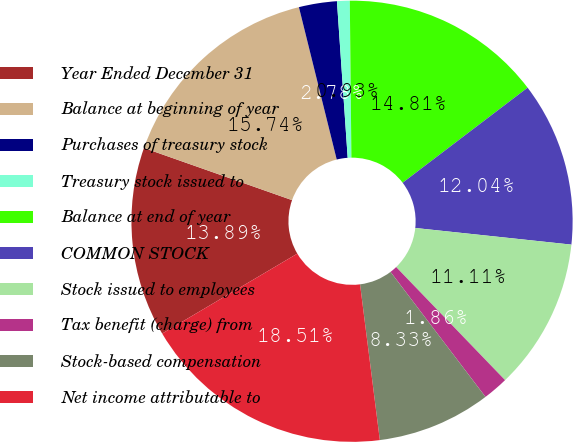Convert chart. <chart><loc_0><loc_0><loc_500><loc_500><pie_chart><fcel>Year Ended December 31<fcel>Balance at beginning of year<fcel>Purchases of treasury stock<fcel>Treasury stock issued to<fcel>Balance at end of year<fcel>COMMON STOCK<fcel>Stock issued to employees<fcel>Tax benefit (charge) from<fcel>Stock-based compensation<fcel>Net income attributable to<nl><fcel>13.89%<fcel>15.74%<fcel>2.78%<fcel>0.93%<fcel>14.81%<fcel>12.04%<fcel>11.11%<fcel>1.86%<fcel>8.33%<fcel>18.51%<nl></chart> 